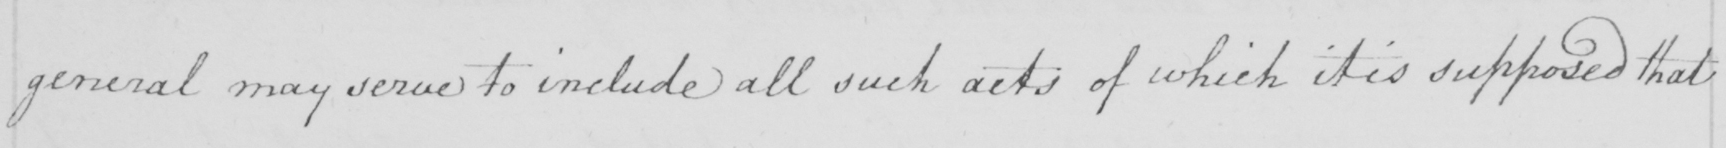Transcribe the text shown in this historical manuscript line. general may serve to include all such acts of which it is supposed that 